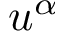<formula> <loc_0><loc_0><loc_500><loc_500>u ^ { \alpha }</formula> 